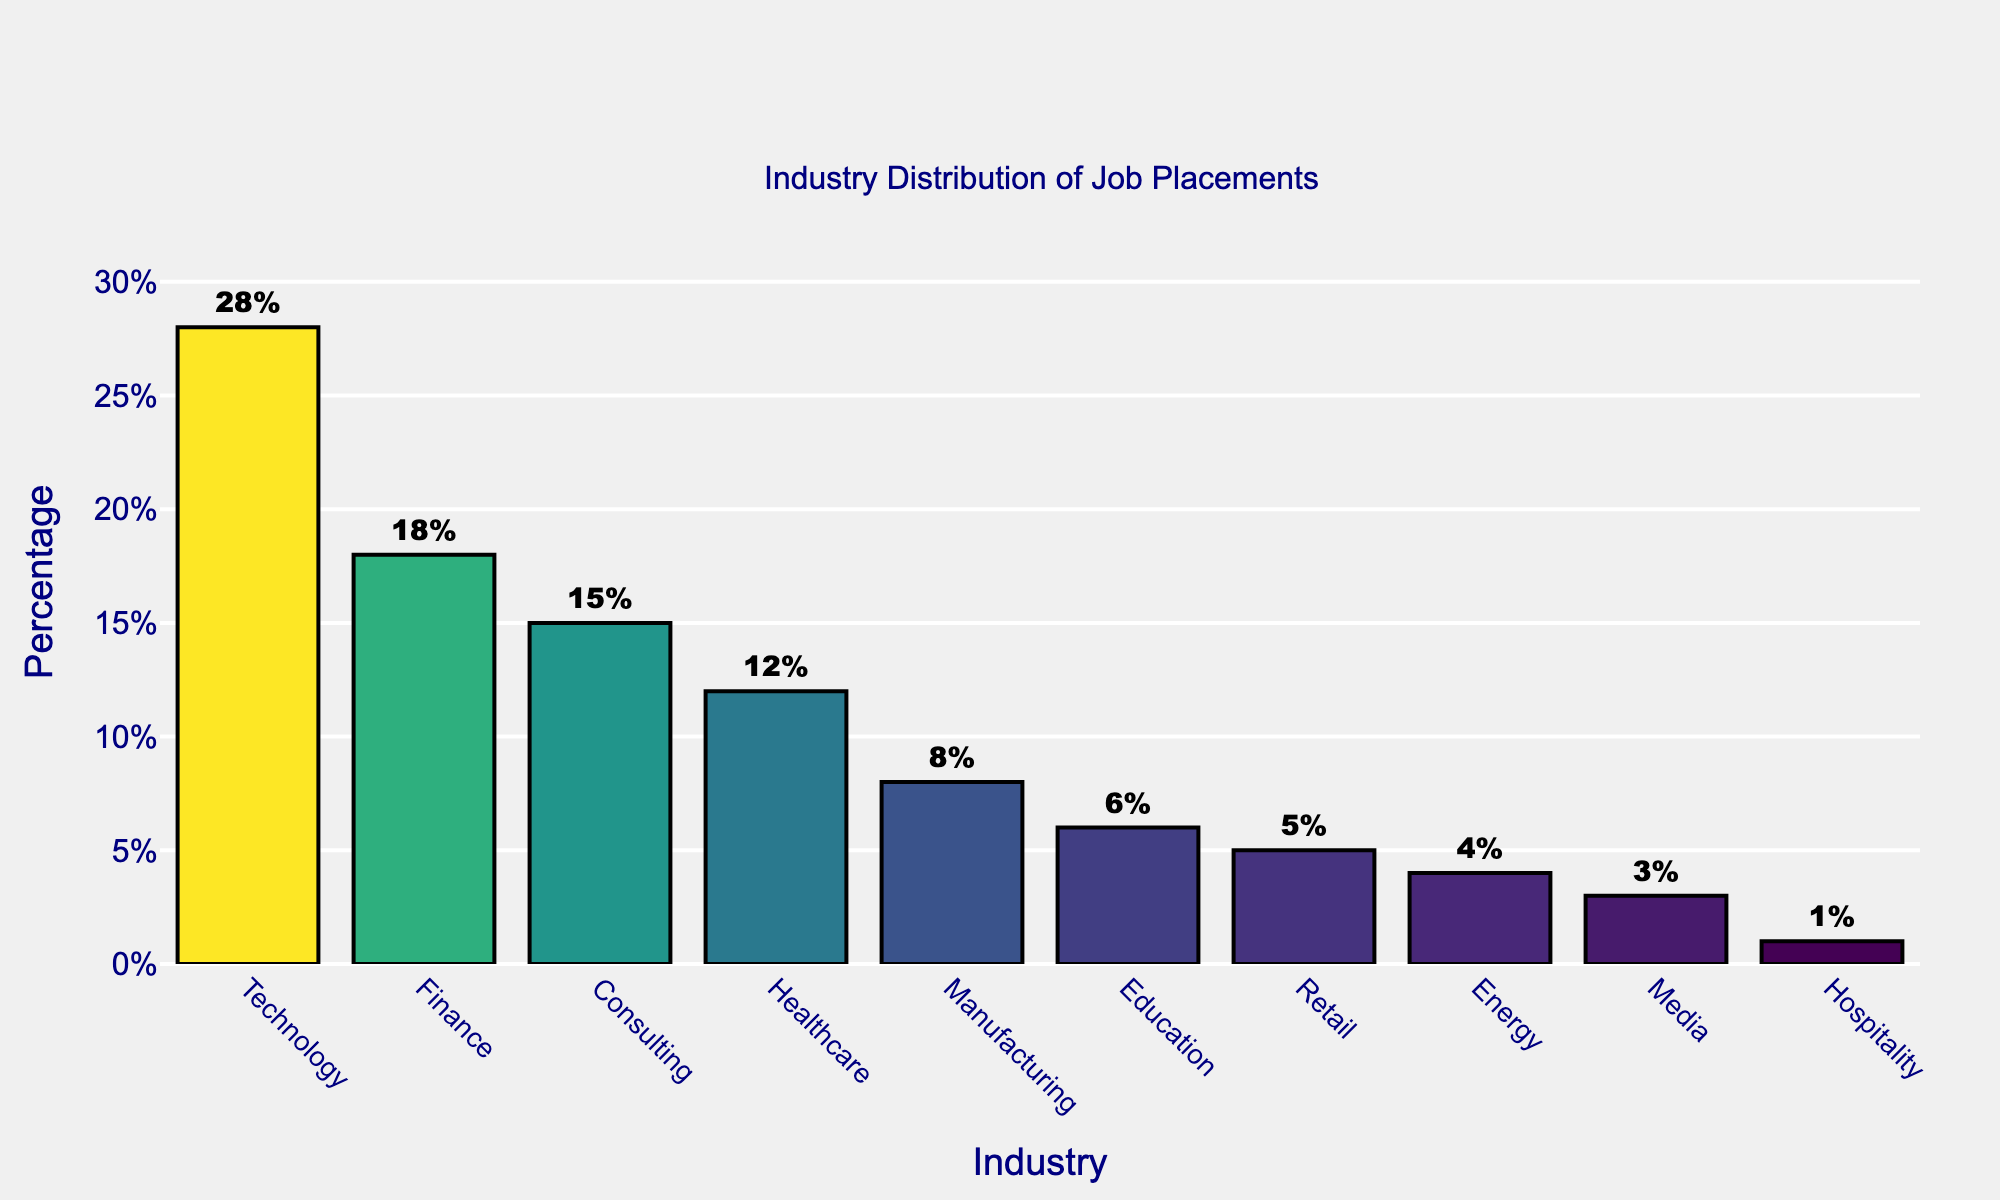What percentage of job placements is in the Technology industry? The bar chart shows the percentage of job placements by industry. The Technology industry has a bar with a text label indicating 28%.
Answer: 28% Which industry has the smallest percentage of job placements? By looking at the height of the bars, Hospitality has the shortest bar and a text label indicating 1%.
Answer: Hospitality What is the difference in job placement percentages between Finance and Healthcare industries? Subtract the percentage of the Healthcare industry (12%) from the Finance industry (18%). 18% - 12% = 6%.
Answer: 6% Are there more job placements in the Consulting industry or in the Retail industry? The chart shows a bar for Consulting labeled with 15% and one for Retail labeled with 5%. Consulting has a higher percentage.
Answer: Consulting Which three industries together have the highest job placements? The bars for Technology (28%), Finance (18%), and Consulting (15%) have the highest values. Adding them together: 28% + 18% + 15% = 61%.
Answer: Technology, Finance, Consulting How many industries have a job placement percentage greater than 10%? By visually inspecting the bars, Technology (28%), Finance (18%), Consulting (15%), and Healthcare (12%) all exceed 10%. There are 4 industries.
Answer: 4 By what percentage does the Technology industry lead over the Manufacturing industry in job placements? Subtract the percentage of the Manufacturing industry (8%) from the Technology industry (28%). 28% - 8% = 20%.
Answer: 20% Which industry occupies the middle position in terms of job placement percentage? Sorting the percentages: Technology (28%), Finance (18%), Consulting (15%), Healthcare (12%), Manufacturing (8%), Education (6%), Retail (5%), Energy (4%), Media (3%), Hospitality (1%). The middle position (5th/6th) is Manufacturing (8%).
Answer: Manufacturing What is the collective job placement percentage for the Education, Retail, and Energy industries? Sum the percentages for Education (6%), Retail (5%), and Energy (4%). 6% + 5% + 4% = 15%.
Answer: 15% Which industry has a bar colored with the darkest shade? The bar colors represent the percentage values, with higher percentages being darker. Technology (28%) has the darkest shade.
Answer: Technology 